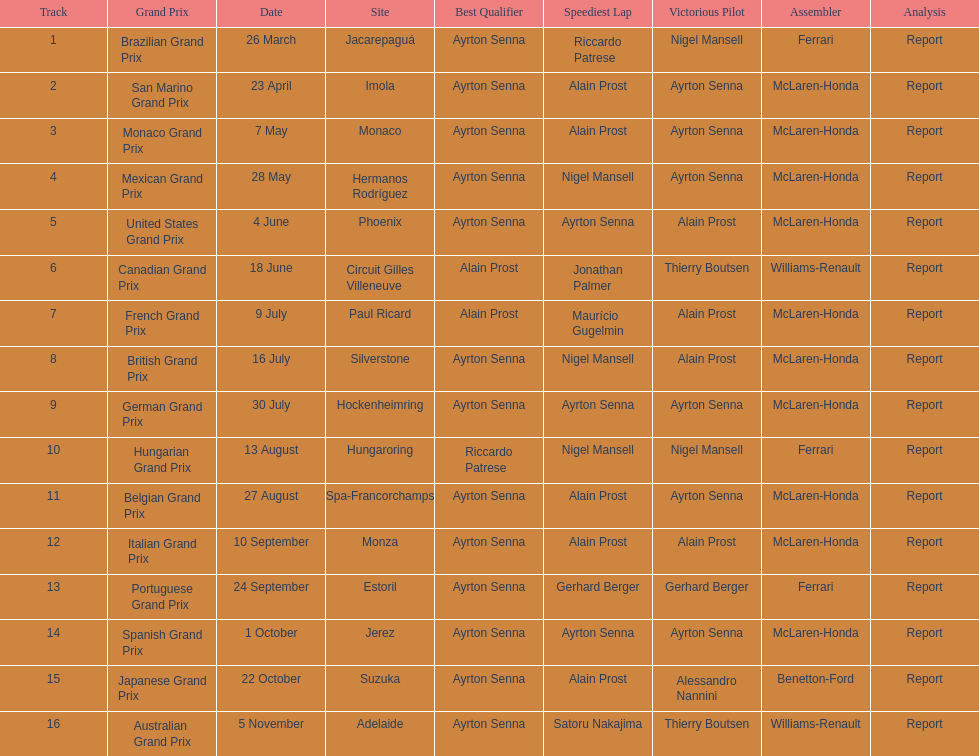Who had the fastest lap at the german grand prix? Ayrton Senna. 